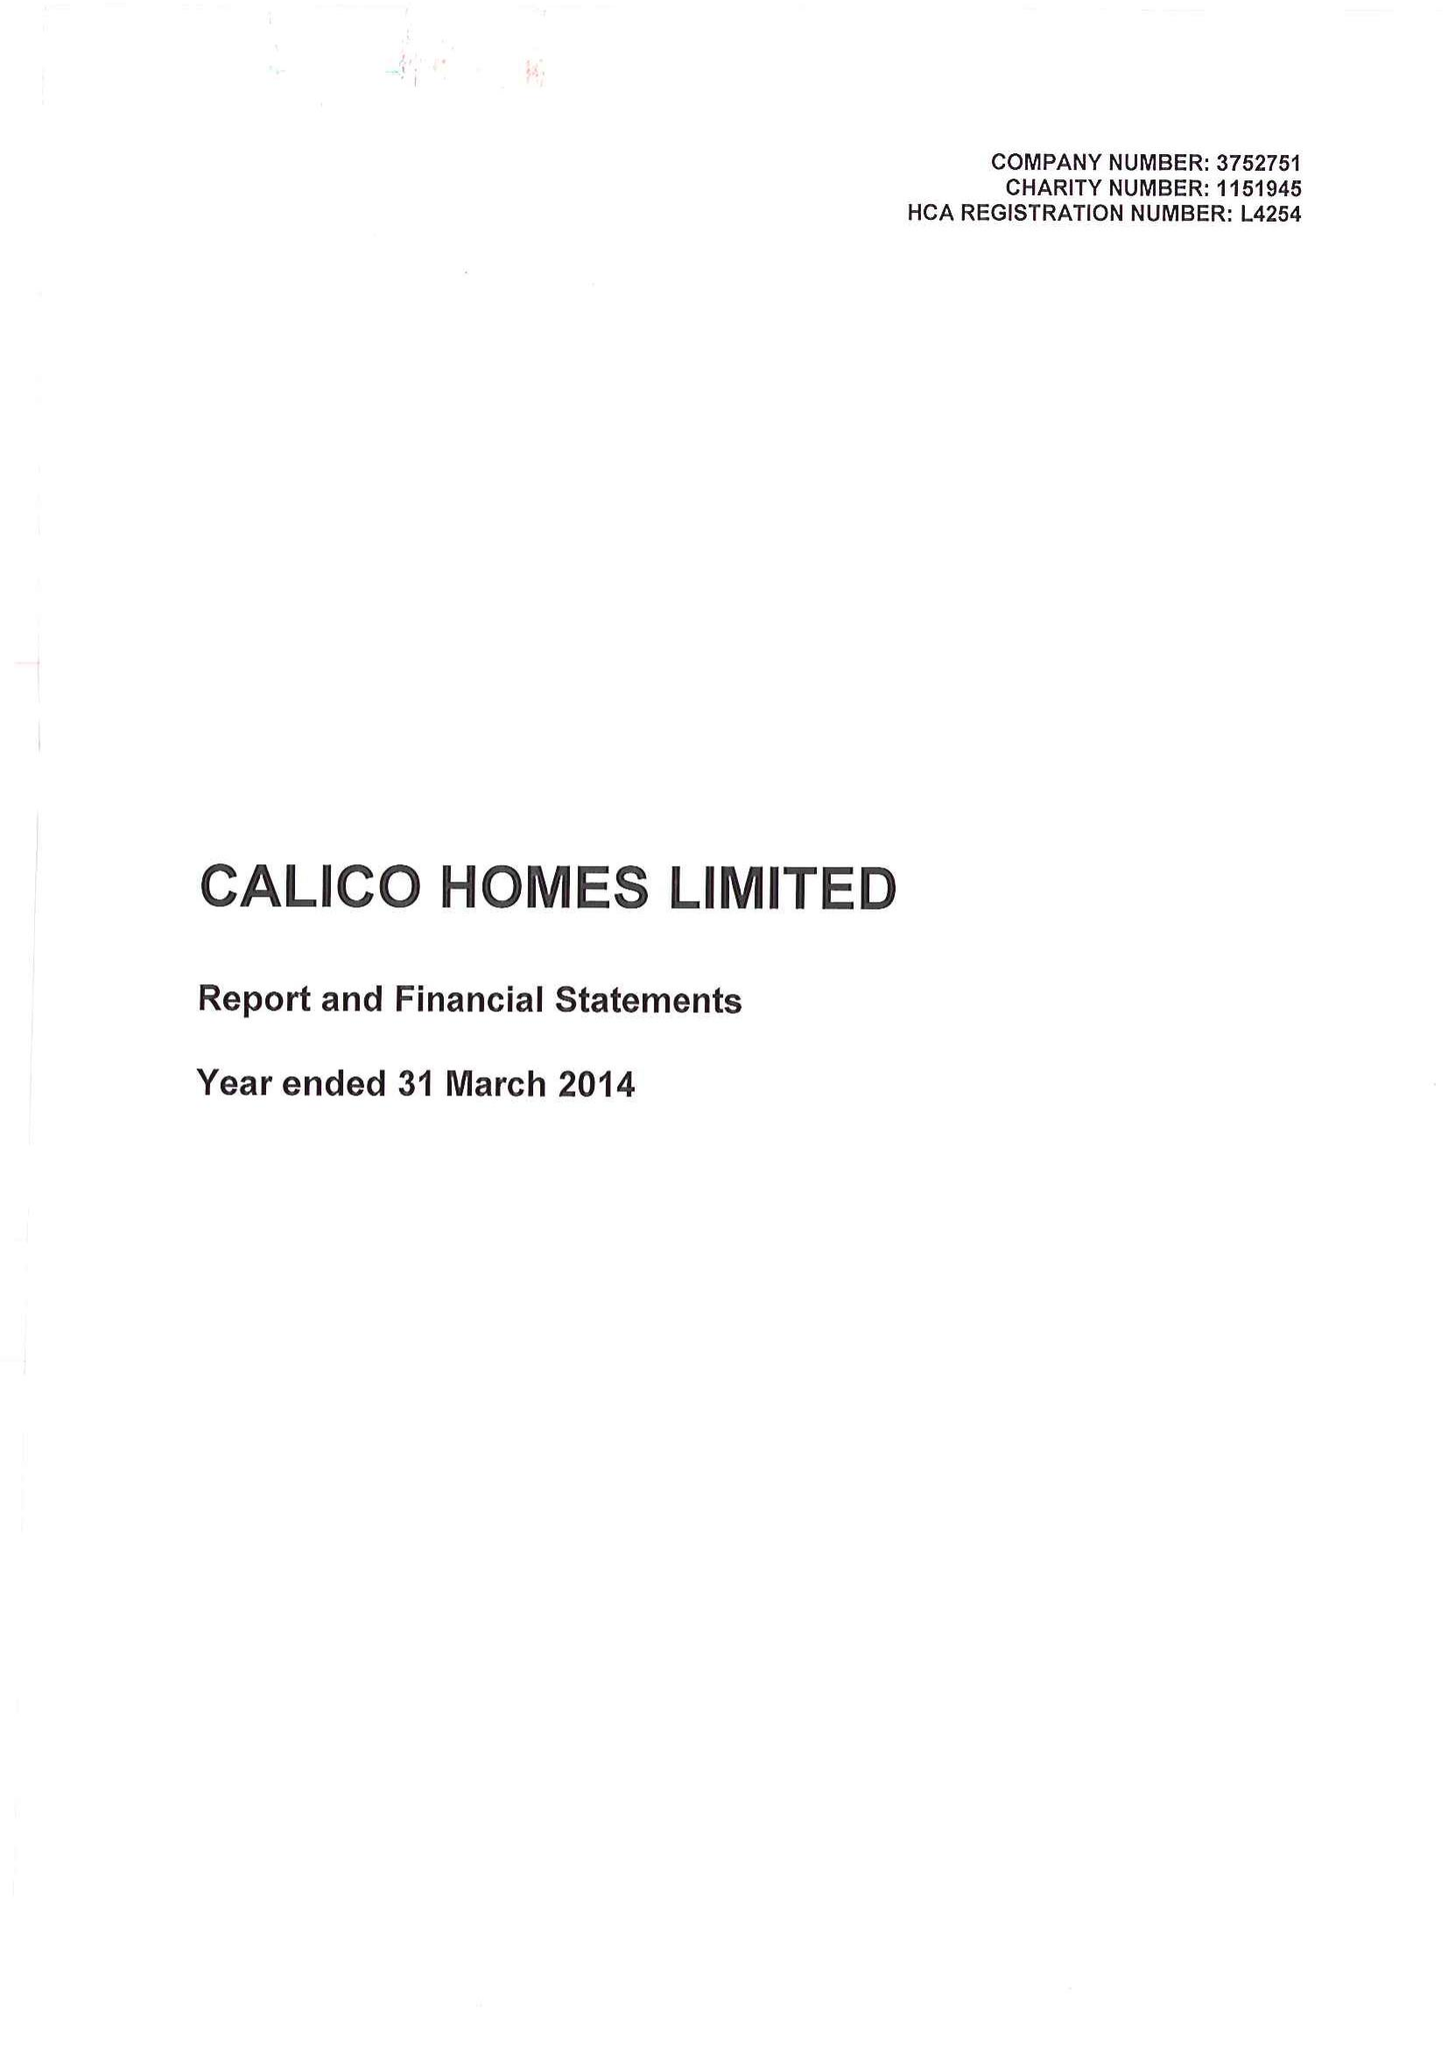What is the value for the report_date?
Answer the question using a single word or phrase. 2014-03-31 